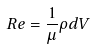Convert formula to latex. <formula><loc_0><loc_0><loc_500><loc_500>R e = \frac { 1 } { \mu } \rho d V</formula> 